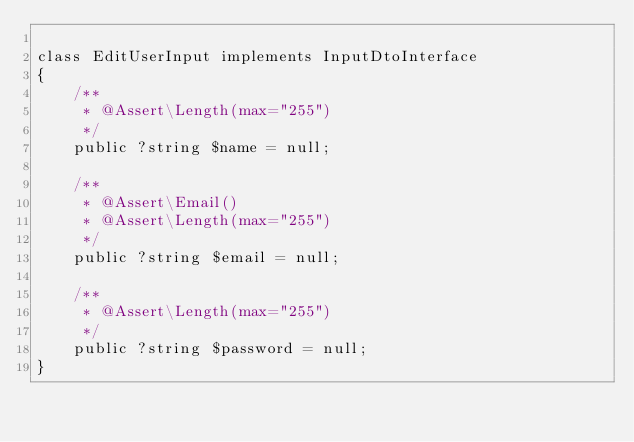<code> <loc_0><loc_0><loc_500><loc_500><_PHP_>
class EditUserInput implements InputDtoInterface
{
    /**
     * @Assert\Length(max="255")
     */
    public ?string $name = null;

    /**
     * @Assert\Email()
     * @Assert\Length(max="255")
     */
    public ?string $email = null;

    /**
     * @Assert\Length(max="255")
     */
    public ?string $password = null;
}
</code> 